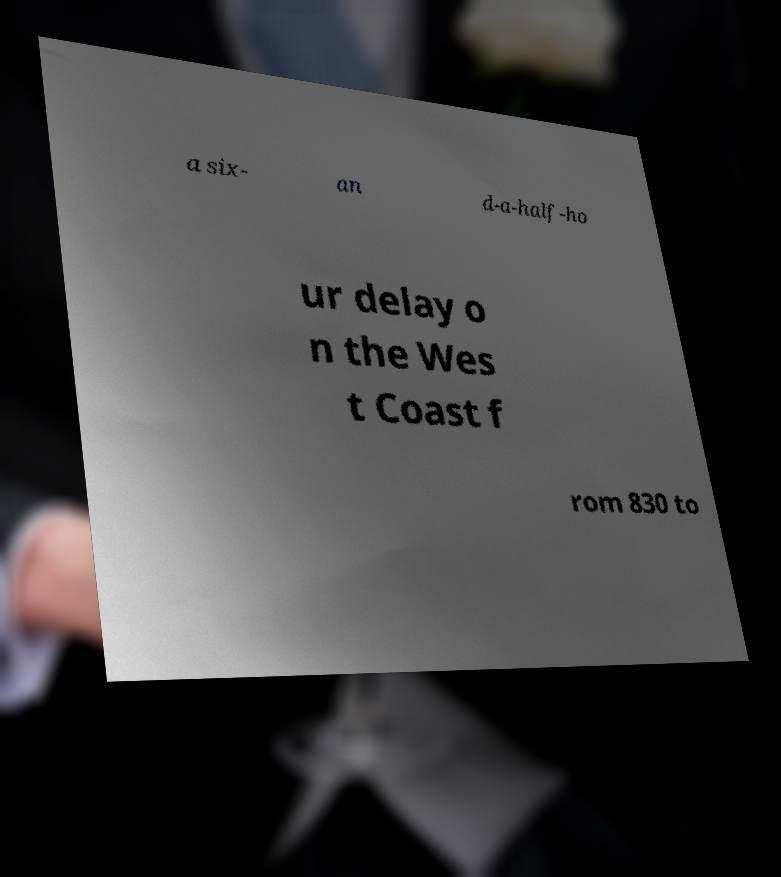Please identify and transcribe the text found in this image. a six- an d-a-half-ho ur delay o n the Wes t Coast f rom 830 to 